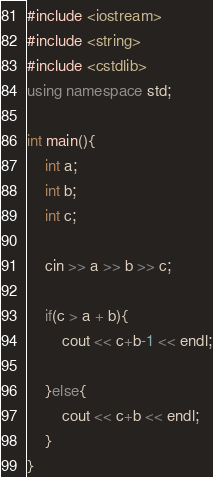Convert code to text. <code><loc_0><loc_0><loc_500><loc_500><_C++_>#include <iostream>
#include <string>
#include <cstdlib>
using namespace std;

int main(){
    int a;
    int b;
    int c;
    
    cin >> a >> b >> c;

    if(c > a + b){
        cout << c+b-1 << endl;
        
    }else{
        cout << c+b << endl;
    }
}</code> 